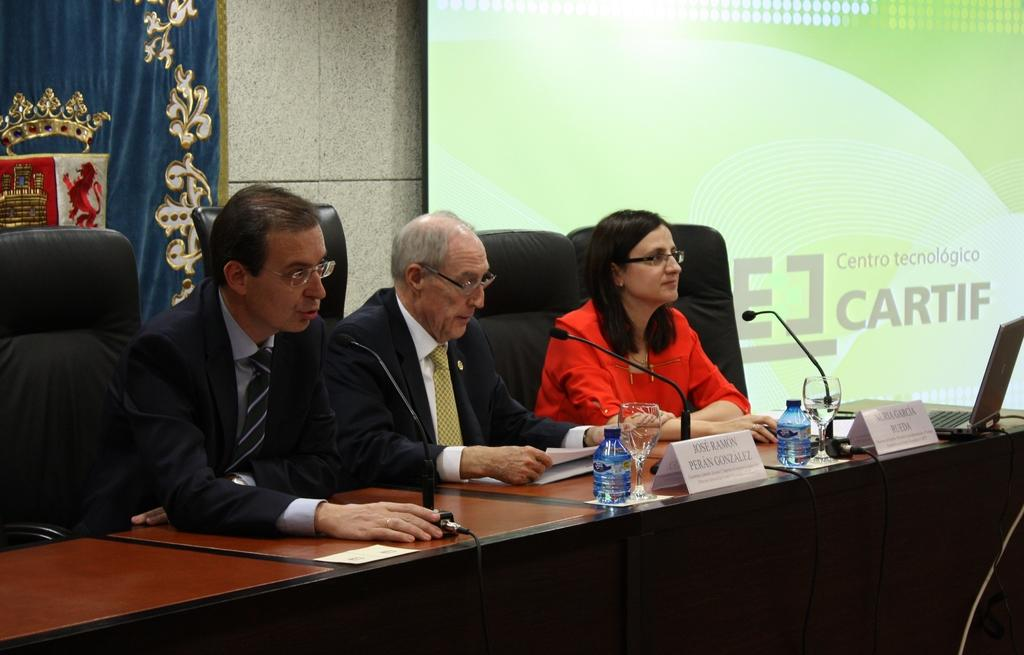What type of structure can be seen in the image? There is a wall in the image. What is located on the wall? There is a screen on the wall. How many people are sitting in the image? There are three people sitting on chairs in the image. What is on the table in the image? There are bottles, a mic, a glass, and a laptop on the table. What type of wire is present in the image? There is no wire present in the image. 